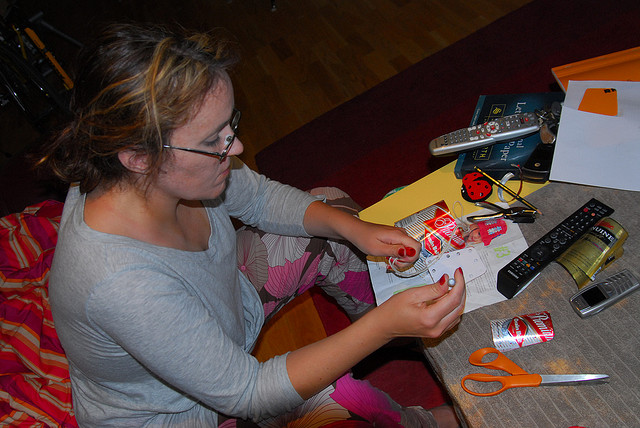<image>What room is pictured with a bed? I don't know. The room with a bed can be a bedroom or a living room. What is in the small yellow box? I don't know what is in the small yellow box. It may not be visible in the image. What event is being celebrated here? It is ambiguous. It can be a birthday, crafting, or even no event. What room is pictured with a bed? I am not sure the room pictured with a bed. It can be seen both bedroom and living room. What is in the small yellow box? It is unanswerable what is in the small yellow box. There are conflicting answers and it is not clear from the given information. What event is being celebrated here? I am not sure what event is being celebrated in the image. It can be seen birthday, crafting, weekend, or marriage. 